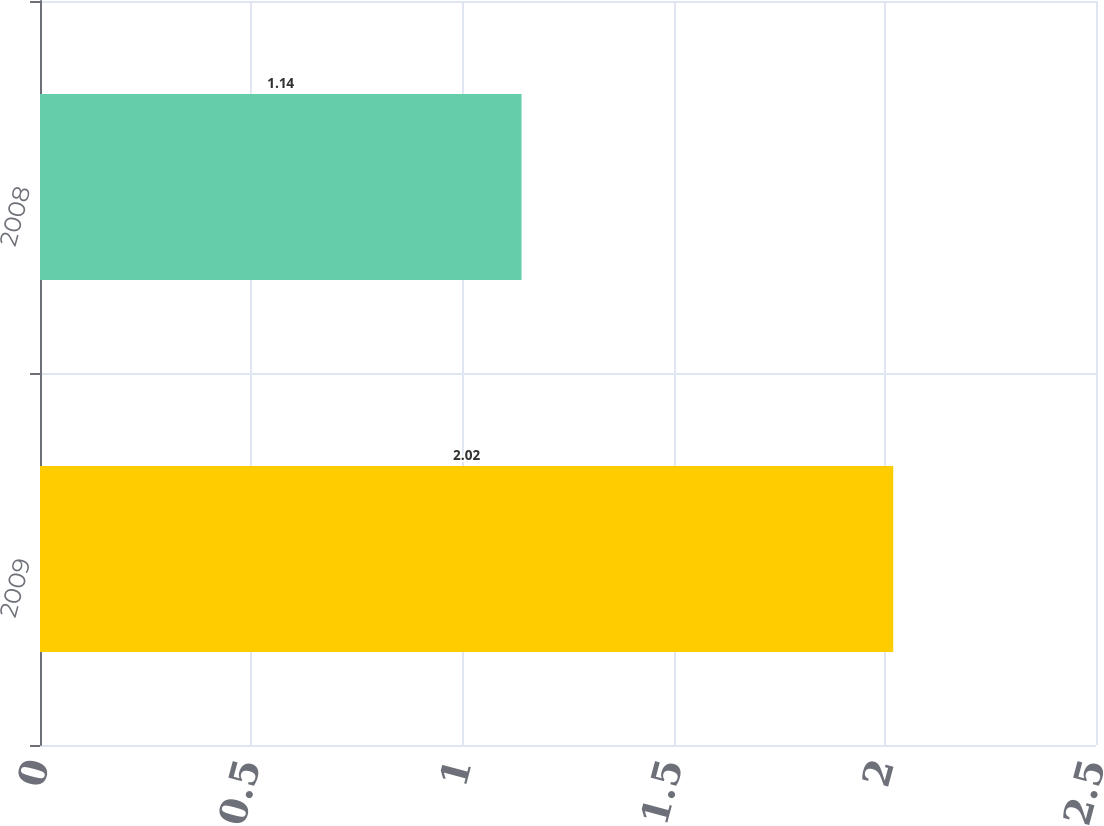<chart> <loc_0><loc_0><loc_500><loc_500><bar_chart><fcel>2009<fcel>2008<nl><fcel>2.02<fcel>1.14<nl></chart> 